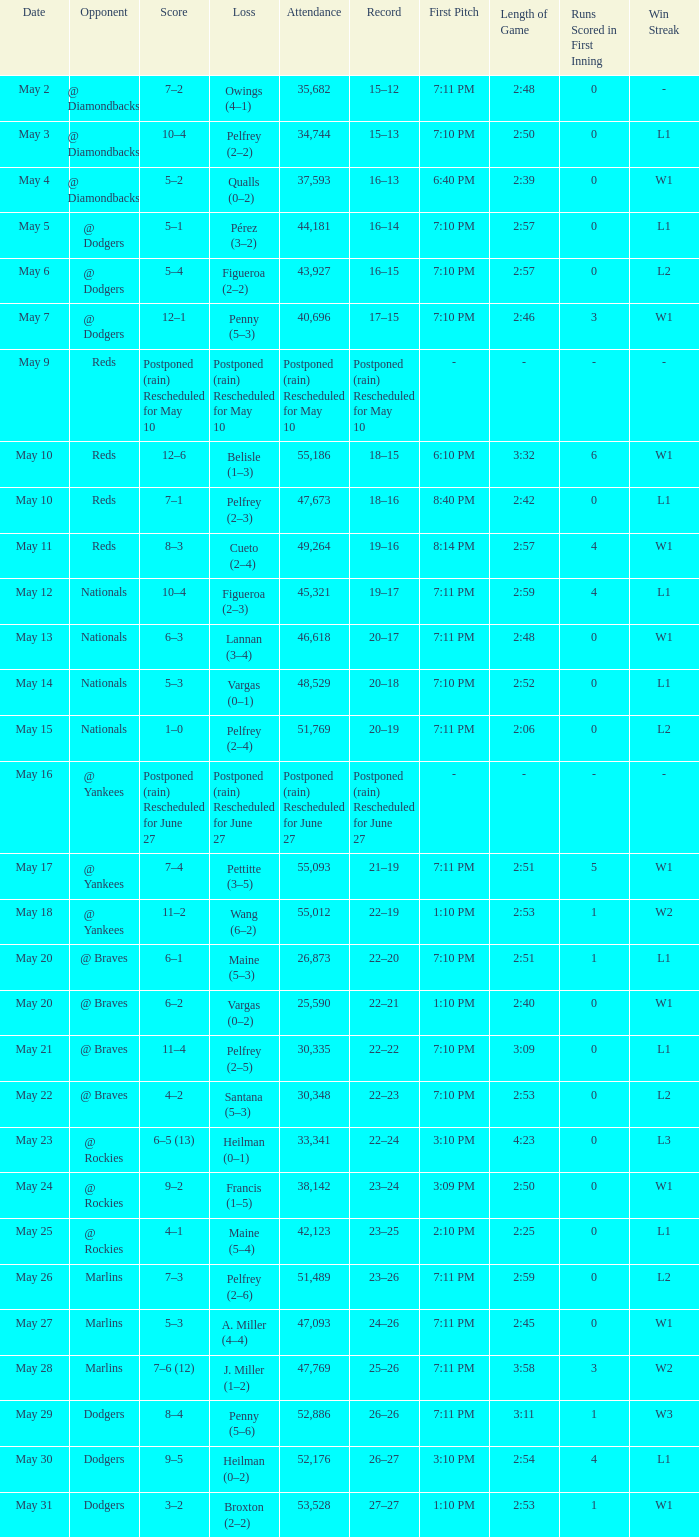Loss of postponed (rain) rescheduled for may 10 had what record? Postponed (rain) Rescheduled for May 10. 